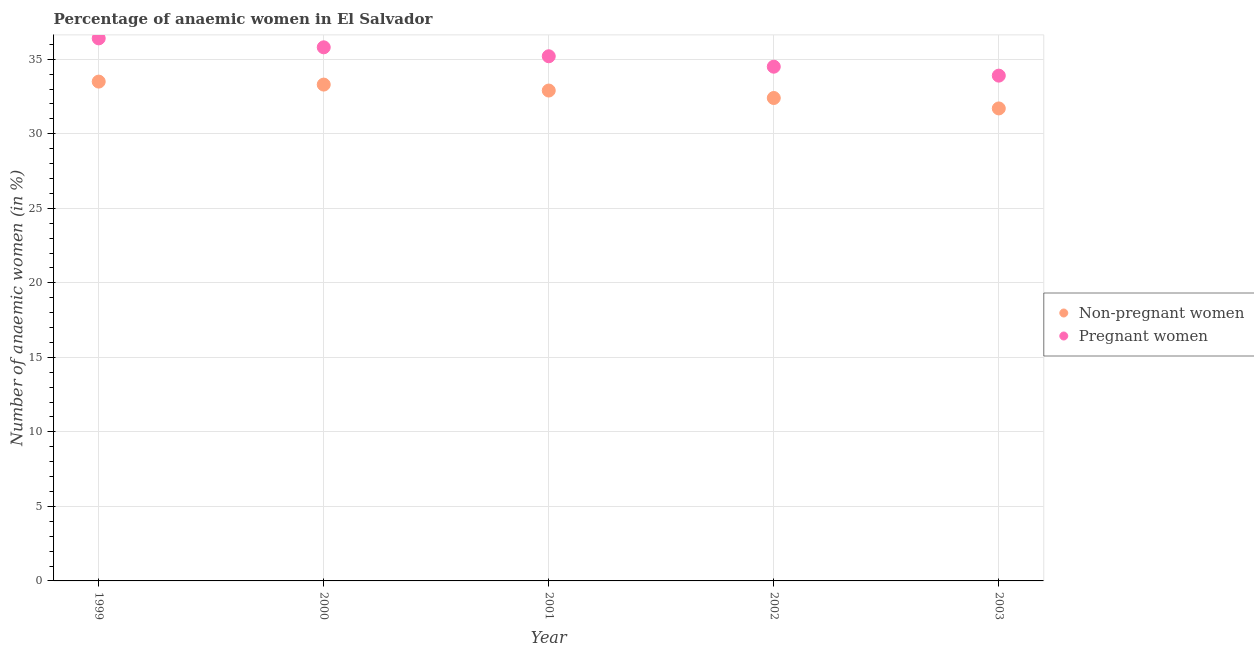How many different coloured dotlines are there?
Offer a very short reply. 2. Is the number of dotlines equal to the number of legend labels?
Provide a short and direct response. Yes. What is the percentage of pregnant anaemic women in 2001?
Ensure brevity in your answer.  35.2. Across all years, what is the maximum percentage of pregnant anaemic women?
Make the answer very short. 36.4. Across all years, what is the minimum percentage of non-pregnant anaemic women?
Provide a short and direct response. 31.7. In which year was the percentage of non-pregnant anaemic women maximum?
Provide a succinct answer. 1999. What is the total percentage of pregnant anaemic women in the graph?
Your answer should be compact. 175.8. What is the difference between the percentage of pregnant anaemic women in 2001 and that in 2002?
Keep it short and to the point. 0.7. What is the difference between the percentage of pregnant anaemic women in 2002 and the percentage of non-pregnant anaemic women in 2000?
Ensure brevity in your answer.  1.2. What is the average percentage of non-pregnant anaemic women per year?
Offer a terse response. 32.76. In the year 2002, what is the difference between the percentage of pregnant anaemic women and percentage of non-pregnant anaemic women?
Offer a terse response. 2.1. In how many years, is the percentage of pregnant anaemic women greater than 15 %?
Offer a terse response. 5. What is the ratio of the percentage of pregnant anaemic women in 2000 to that in 2002?
Ensure brevity in your answer.  1.04. Is the percentage of pregnant anaemic women in 2002 less than that in 2003?
Offer a terse response. No. What is the difference between the highest and the second highest percentage of pregnant anaemic women?
Provide a short and direct response. 0.6. What is the difference between the highest and the lowest percentage of non-pregnant anaemic women?
Make the answer very short. 1.8. In how many years, is the percentage of non-pregnant anaemic women greater than the average percentage of non-pregnant anaemic women taken over all years?
Keep it short and to the point. 3. How many dotlines are there?
Ensure brevity in your answer.  2. Are the values on the major ticks of Y-axis written in scientific E-notation?
Provide a short and direct response. No. Does the graph contain grids?
Ensure brevity in your answer.  Yes. What is the title of the graph?
Make the answer very short. Percentage of anaemic women in El Salvador. Does "Urban agglomerations" appear as one of the legend labels in the graph?
Provide a succinct answer. No. What is the label or title of the X-axis?
Offer a terse response. Year. What is the label or title of the Y-axis?
Ensure brevity in your answer.  Number of anaemic women (in %). What is the Number of anaemic women (in %) of Non-pregnant women in 1999?
Ensure brevity in your answer.  33.5. What is the Number of anaemic women (in %) in Pregnant women in 1999?
Make the answer very short. 36.4. What is the Number of anaemic women (in %) of Non-pregnant women in 2000?
Provide a succinct answer. 33.3. What is the Number of anaemic women (in %) in Pregnant women in 2000?
Your answer should be compact. 35.8. What is the Number of anaemic women (in %) in Non-pregnant women in 2001?
Make the answer very short. 32.9. What is the Number of anaemic women (in %) in Pregnant women in 2001?
Make the answer very short. 35.2. What is the Number of anaemic women (in %) of Non-pregnant women in 2002?
Make the answer very short. 32.4. What is the Number of anaemic women (in %) in Pregnant women in 2002?
Keep it short and to the point. 34.5. What is the Number of anaemic women (in %) of Non-pregnant women in 2003?
Give a very brief answer. 31.7. What is the Number of anaemic women (in %) in Pregnant women in 2003?
Offer a terse response. 33.9. Across all years, what is the maximum Number of anaemic women (in %) of Non-pregnant women?
Give a very brief answer. 33.5. Across all years, what is the maximum Number of anaemic women (in %) of Pregnant women?
Your response must be concise. 36.4. Across all years, what is the minimum Number of anaemic women (in %) in Non-pregnant women?
Your answer should be very brief. 31.7. Across all years, what is the minimum Number of anaemic women (in %) in Pregnant women?
Keep it short and to the point. 33.9. What is the total Number of anaemic women (in %) in Non-pregnant women in the graph?
Keep it short and to the point. 163.8. What is the total Number of anaemic women (in %) in Pregnant women in the graph?
Your response must be concise. 175.8. What is the difference between the Number of anaemic women (in %) of Non-pregnant women in 1999 and that in 2000?
Offer a terse response. 0.2. What is the difference between the Number of anaemic women (in %) in Non-pregnant women in 1999 and that in 2001?
Ensure brevity in your answer.  0.6. What is the difference between the Number of anaemic women (in %) of Pregnant women in 1999 and that in 2001?
Offer a very short reply. 1.2. What is the difference between the Number of anaemic women (in %) in Non-pregnant women in 1999 and that in 2002?
Your answer should be very brief. 1.1. What is the difference between the Number of anaemic women (in %) in Pregnant women in 1999 and that in 2002?
Provide a succinct answer. 1.9. What is the difference between the Number of anaemic women (in %) in Non-pregnant women in 1999 and that in 2003?
Make the answer very short. 1.8. What is the difference between the Number of anaemic women (in %) of Non-pregnant women in 2000 and that in 2001?
Your response must be concise. 0.4. What is the difference between the Number of anaemic women (in %) in Pregnant women in 2000 and that in 2001?
Offer a very short reply. 0.6. What is the difference between the Number of anaemic women (in %) in Non-pregnant women in 2000 and that in 2002?
Your answer should be very brief. 0.9. What is the difference between the Number of anaemic women (in %) of Non-pregnant women in 2000 and that in 2003?
Provide a succinct answer. 1.6. What is the difference between the Number of anaemic women (in %) of Pregnant women in 2000 and that in 2003?
Keep it short and to the point. 1.9. What is the difference between the Number of anaemic women (in %) of Non-pregnant women in 2001 and that in 2003?
Give a very brief answer. 1.2. What is the difference between the Number of anaemic women (in %) in Pregnant women in 2001 and that in 2003?
Provide a short and direct response. 1.3. What is the difference between the Number of anaemic women (in %) in Non-pregnant women in 2002 and that in 2003?
Ensure brevity in your answer.  0.7. What is the difference between the Number of anaemic women (in %) in Pregnant women in 2002 and that in 2003?
Provide a short and direct response. 0.6. What is the difference between the Number of anaemic women (in %) in Non-pregnant women in 1999 and the Number of anaemic women (in %) in Pregnant women in 2001?
Offer a terse response. -1.7. What is the difference between the Number of anaemic women (in %) in Non-pregnant women in 2000 and the Number of anaemic women (in %) in Pregnant women in 2001?
Keep it short and to the point. -1.9. What is the difference between the Number of anaemic women (in %) in Non-pregnant women in 2000 and the Number of anaemic women (in %) in Pregnant women in 2003?
Offer a terse response. -0.6. What is the average Number of anaemic women (in %) in Non-pregnant women per year?
Offer a very short reply. 32.76. What is the average Number of anaemic women (in %) of Pregnant women per year?
Give a very brief answer. 35.16. In the year 1999, what is the difference between the Number of anaemic women (in %) of Non-pregnant women and Number of anaemic women (in %) of Pregnant women?
Provide a succinct answer. -2.9. In the year 2002, what is the difference between the Number of anaemic women (in %) in Non-pregnant women and Number of anaemic women (in %) in Pregnant women?
Provide a short and direct response. -2.1. What is the ratio of the Number of anaemic women (in %) in Non-pregnant women in 1999 to that in 2000?
Offer a terse response. 1.01. What is the ratio of the Number of anaemic women (in %) in Pregnant women in 1999 to that in 2000?
Provide a short and direct response. 1.02. What is the ratio of the Number of anaemic women (in %) in Non-pregnant women in 1999 to that in 2001?
Your answer should be compact. 1.02. What is the ratio of the Number of anaemic women (in %) of Pregnant women in 1999 to that in 2001?
Offer a very short reply. 1.03. What is the ratio of the Number of anaemic women (in %) of Non-pregnant women in 1999 to that in 2002?
Ensure brevity in your answer.  1.03. What is the ratio of the Number of anaemic women (in %) of Pregnant women in 1999 to that in 2002?
Provide a succinct answer. 1.06. What is the ratio of the Number of anaemic women (in %) of Non-pregnant women in 1999 to that in 2003?
Ensure brevity in your answer.  1.06. What is the ratio of the Number of anaemic women (in %) in Pregnant women in 1999 to that in 2003?
Provide a succinct answer. 1.07. What is the ratio of the Number of anaemic women (in %) in Non-pregnant women in 2000 to that in 2001?
Your answer should be compact. 1.01. What is the ratio of the Number of anaemic women (in %) of Pregnant women in 2000 to that in 2001?
Offer a terse response. 1.02. What is the ratio of the Number of anaemic women (in %) of Non-pregnant women in 2000 to that in 2002?
Give a very brief answer. 1.03. What is the ratio of the Number of anaemic women (in %) in Pregnant women in 2000 to that in 2002?
Your answer should be compact. 1.04. What is the ratio of the Number of anaemic women (in %) in Non-pregnant women in 2000 to that in 2003?
Offer a terse response. 1.05. What is the ratio of the Number of anaemic women (in %) of Pregnant women in 2000 to that in 2003?
Provide a succinct answer. 1.06. What is the ratio of the Number of anaemic women (in %) of Non-pregnant women in 2001 to that in 2002?
Make the answer very short. 1.02. What is the ratio of the Number of anaemic women (in %) in Pregnant women in 2001 to that in 2002?
Keep it short and to the point. 1.02. What is the ratio of the Number of anaemic women (in %) in Non-pregnant women in 2001 to that in 2003?
Offer a terse response. 1.04. What is the ratio of the Number of anaemic women (in %) of Pregnant women in 2001 to that in 2003?
Provide a short and direct response. 1.04. What is the ratio of the Number of anaemic women (in %) in Non-pregnant women in 2002 to that in 2003?
Ensure brevity in your answer.  1.02. What is the ratio of the Number of anaemic women (in %) in Pregnant women in 2002 to that in 2003?
Make the answer very short. 1.02. What is the difference between the highest and the second highest Number of anaemic women (in %) of Non-pregnant women?
Keep it short and to the point. 0.2. What is the difference between the highest and the lowest Number of anaemic women (in %) in Pregnant women?
Provide a short and direct response. 2.5. 